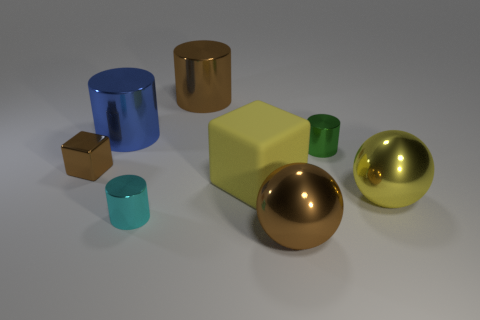Add 1 small shiny cubes. How many objects exist? 9 Subtract all balls. How many objects are left? 6 Add 7 small metallic cylinders. How many small metallic cylinders are left? 9 Add 6 big yellow metallic balls. How many big yellow metallic balls exist? 7 Subtract 1 yellow blocks. How many objects are left? 7 Subtract all large blue things. Subtract all small shiny things. How many objects are left? 4 